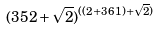<formula> <loc_0><loc_0><loc_500><loc_500>( 3 5 2 + \sqrt { 2 } ) ^ { ( ( 2 + 3 6 1 ) + \sqrt { 2 } ) }</formula> 